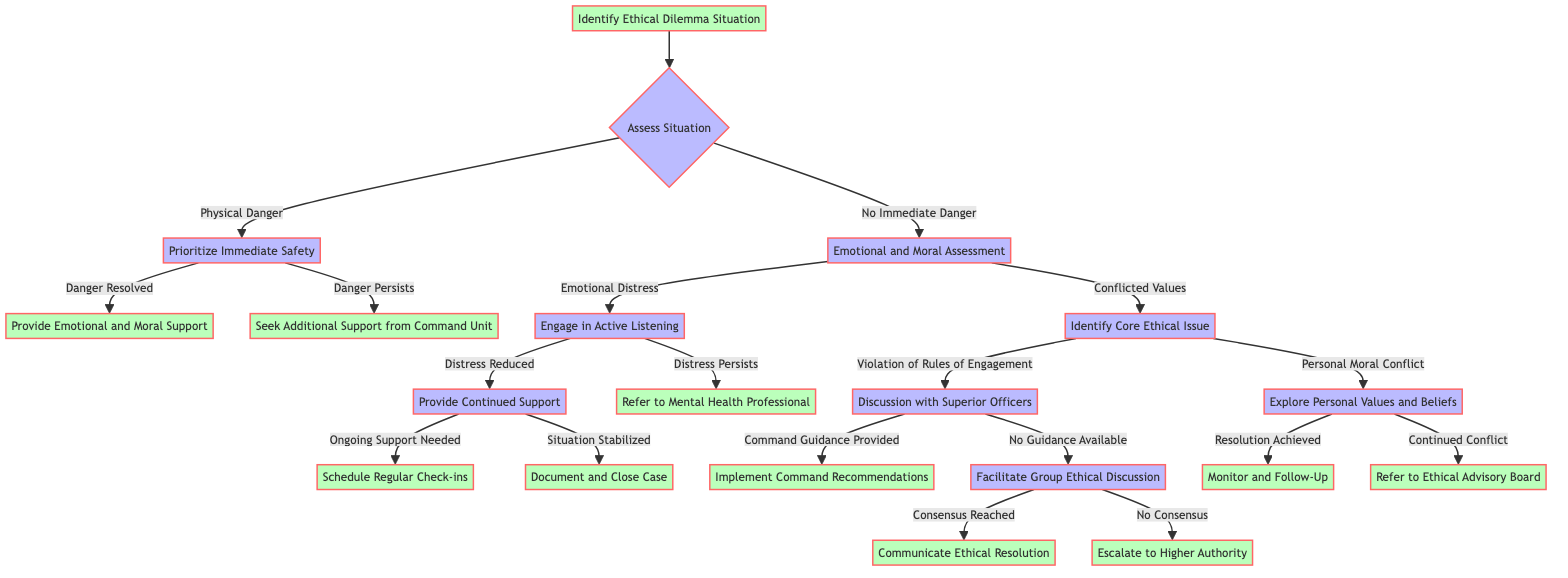What is the starting point of the diagram? The diagram starts at the node labeled "Identify Ethical Dilemma Situation." This is the first node that initiates the flow of the decision-making process in the protocol.
Answer: Identify Ethical Dilemma Situation How many nodes are there in total? The diagram consists of 12 distinct nodes, including the starting point and terminal nodes. Each node represents a step in the crisis intervention protocol.
Answer: 12 What follows after "Assess Situation" if the condition is "No Immediate Danger"? If the condition is "No Immediate Danger," the next step is "Proceed to Emotional and Moral Assessment," indicating a focus on the emotional state rather than immediate safety.
Answer: Proceed to Emotional and Moral Assessment What is the terminal step after "Provide Continued Support" if the situation is stabilized? If the situation is stabilized, the terminal step is "Document and Close Case," signifying that the intervention process has completed successfully.
Answer: Document and Close Case What action is taken if the danger persists after prioritizing immediate safety? If danger persists after prioritizing immediate safety, the next action is "Seek Additional Support from Command Unit," which indicates the need for further assistance.
Answer: Seek Additional Support from Command Unit What happens if emotional distress is assessed during the emotional and moral assessment? If "Emotional Distress" is found during the emotional and moral assessment, the next step is "Engage in Active Listening," which aims to address the emotional needs of the individual in distress.
Answer: Engage in Active Listening What is the outcome after "Discussion with Superior Officers" if command guidance is provided? If "Command Guidance Provided" is achieved after the discussion, the outcome is to "Implement Command Recommendations," reflecting a course of action based on the provided guidance.
Answer: Implement Command Recommendations What is the next step if there is "No Consensus" after facilitating a group ethical discussion? If there is "No Consensus," the next step is to "Escalate to Higher Authority," emphasizing the need for further resolution from a superior authority.
Answer: Escalate to Higher Authority What does "Refer to Ethical Advisory Board" indicate after exploring personal values and beliefs? "Refer to Ethical Advisory Board" indicates that there is "Continued Conflict" in the individual's personal moral conflict, suggesting the issue is complex and requires specialized advice.
Answer: Refer to Ethical Advisory Board 